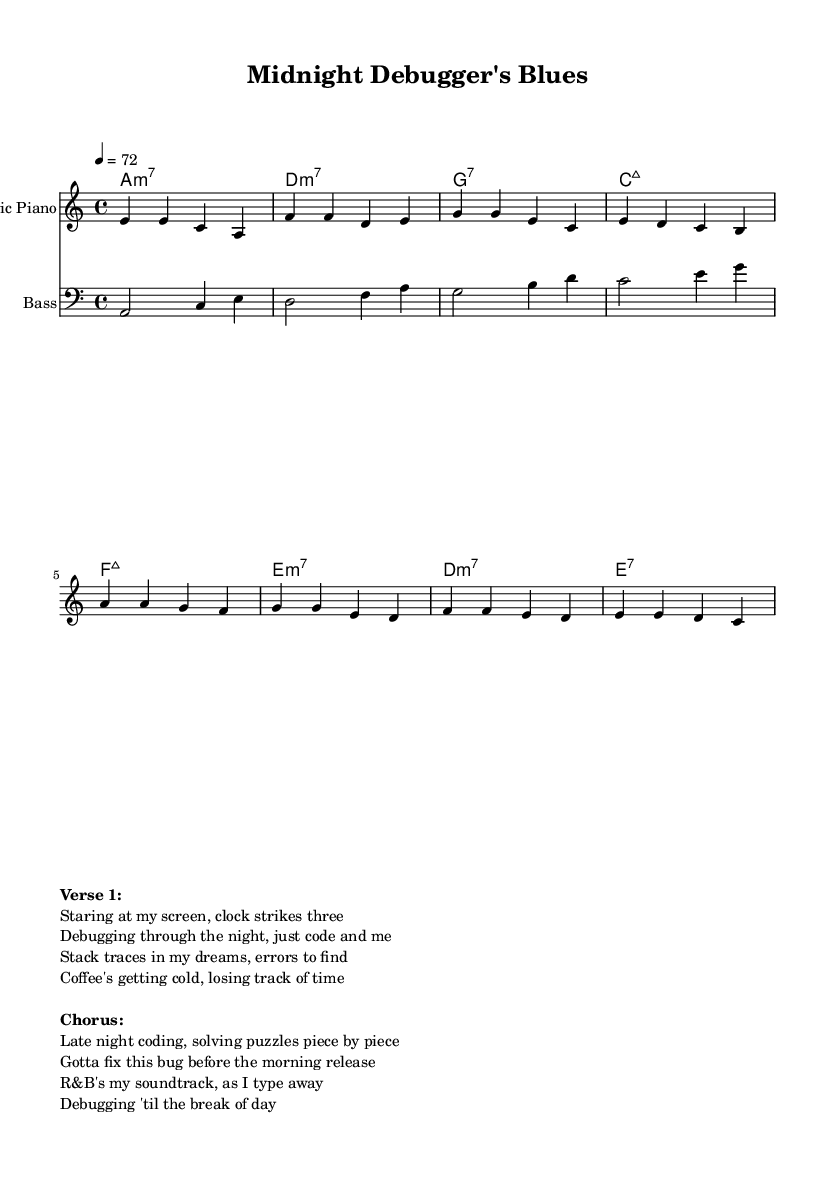What is the key signature of this music? The key signature is A minor, which has no sharps or flats.
Answer: A minor What is the time signature of this music? The time signature is 4/4, indicating four beats per measure.
Answer: 4/4 What is the tempo of the piece? The tempo is set at a quarter note equals 72 beats per minute.
Answer: 72 How many measures are in the verse section? Counting the measures in the verse melody, there are four measures.
Answer: 4 Which instruments are included in this score? The score includes an electric piano and a bass guitar.
Answer: Electric piano and bass guitar What are the primary emotions conveyed in this R&B piece? The lyrics convey feelings of determination and solitude during late-night coding sessions.
Answer: Determination and solitude What type of chord is used at the beginning of the chorus? The first chord used in the chorus is F major 7.
Answer: F major 7 